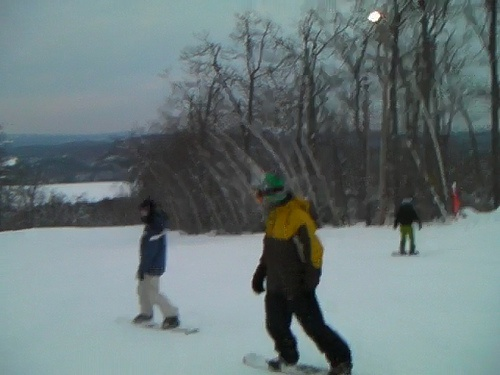Describe the objects in this image and their specific colors. I can see people in gray, black, and olive tones, people in gray, black, navy, and darkgray tones, people in gray, black, darkgreen, and purple tones, snowboard in gray, darkgray, and purple tones, and snowboard in gray and darkgray tones in this image. 